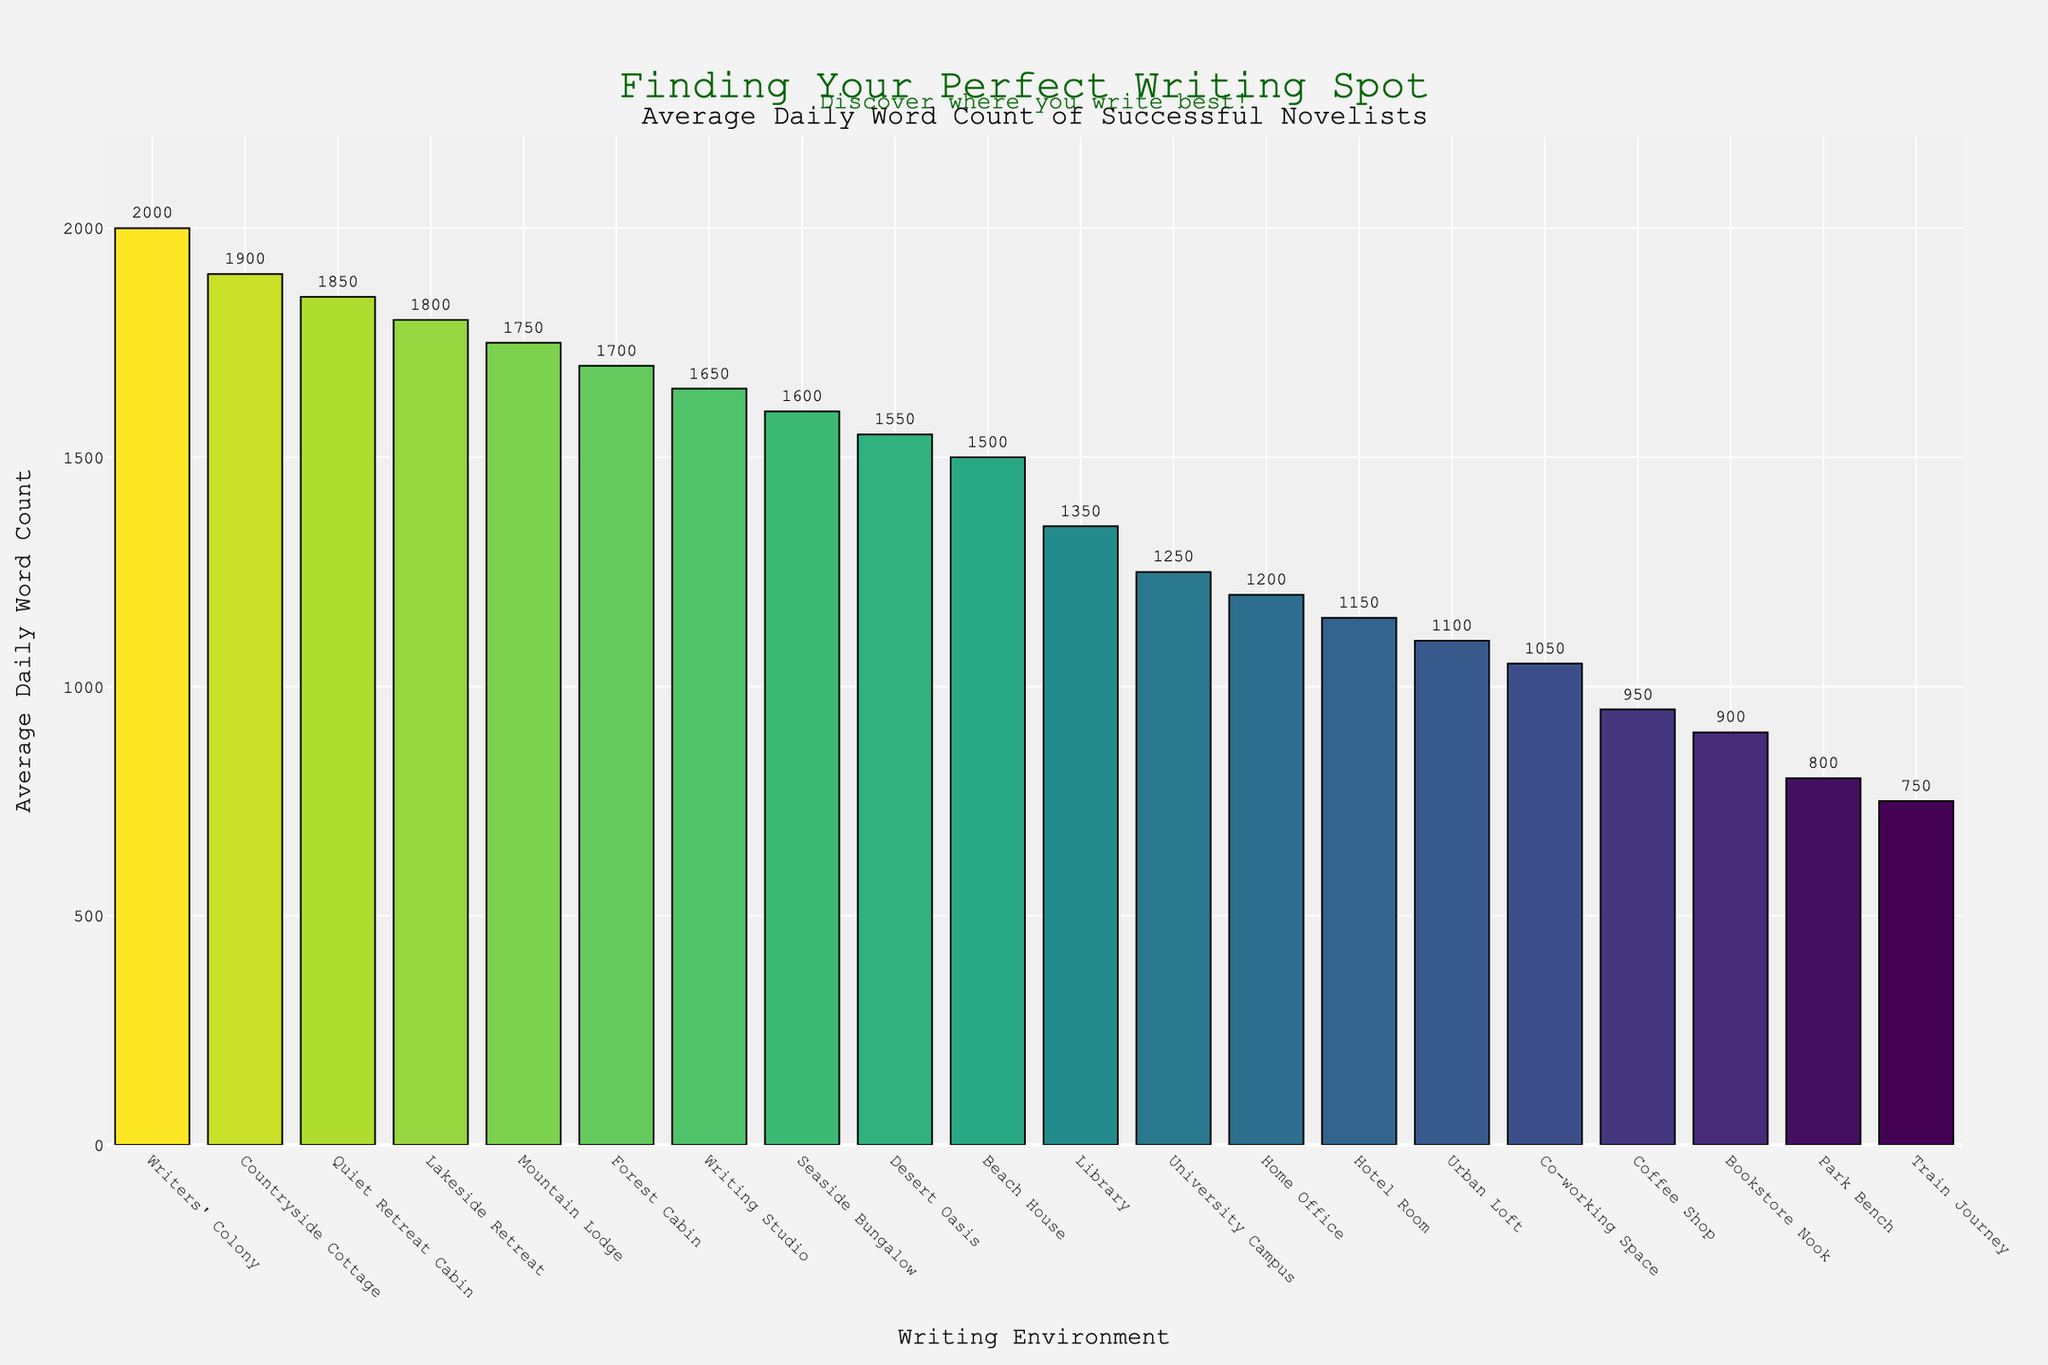What is the writing environment with the highest average daily word count? The writing environment with the highest bar represents the highest average daily word count. The Writers' Colony has the tallest bar reaching 2000 words.
Answer: Writers' Colony Which two environments have almost equal average daily word counts, but less than Writing Studio? We need to look for bars with similar heights that are both less than the Writing Studio's height. Seaside Bungalow and Desert Oasis both have average daily word counts slightly below the Writing Studio's 1650, with 1600 and 1550 respectively, making them nearly equal.
Answer: Seaside Bungalow, Desert Oasis Compare the average daily word count of a Beach House with that of a Home Office. Which one is higher and by how much? The Beach House has an average daily word count of 1500, and the Home Office has 1200. Subtracting the two gives 1500 - 1200 = 300.
Answer: Beach House by 300 What's the combined average daily word count for the environments with the lowest and highest values? The lowest is Train Journey with 750 and the highest is Writers' Colony with 2000. Adding them together gives 750 + 2000 = 2750.
Answer: 2750 Which environment has a higher average daily word count: Library or Urban Loft? The Library has an average of 1350, and the Urban Loft stands at 1100. Comparatively, the Library's word count is higher. The Library's bar is taller than Urban Loft's.
Answer: Library What is the difference in average daily word count between a Quiet Retreat Cabin and a Forest Cabin? The average for Quiet Retreat Cabin is 1850 and for Forest Cabin is 1700. Subtracting these, we get 1850 - 1700 = 150.
Answer: 150 Identify an environment that has an average daily word count of less than 1000, but more than 800. Among the bars representing less than 1000, but more than 800 are the Coffee Shop (950) and Bookstore Nook (900).
Answer: Coffee Shop, Bookstore Nook How does the average daily word count in a Hotel Room compare with a Co-working Space? The Hotel Room has an average of 1150 compared to 1050 in a Co-working Space. Thus, the Hotel Room's bar is slightly taller, indicating a higher word count.
Answer: Hotel Room Calculate the average daily word count for environments labeled as "quiet retreats" (Quiet Retreat Cabin, Forest Cabin, Mountain Lodge, Lakeside Retreat, Countryside Cottage). Add the averages for these environments: 1850 (Quiet Retreat Cabin) + 1700 (Forest Cabin) + 1750 (Mountain Lodge) + 1800 (Lakeside Retreat) + 1900 (Countryside Cottage) = 9000. Then, divide by 5 to find the average: 9000 / 5 = 1800.
Answer: 1800 